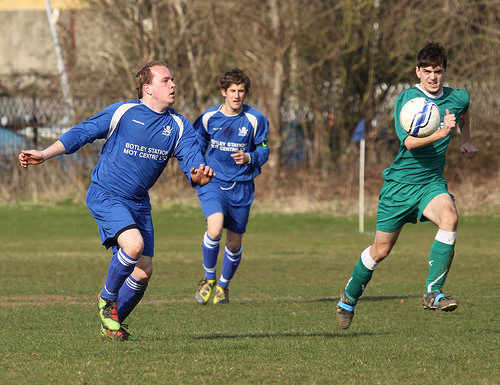<image>
Is the ball to the left of the man? No. The ball is not to the left of the man. From this viewpoint, they have a different horizontal relationship. Is there a soccer ball in front of the player? Yes. The soccer ball is positioned in front of the player, appearing closer to the camera viewpoint. 